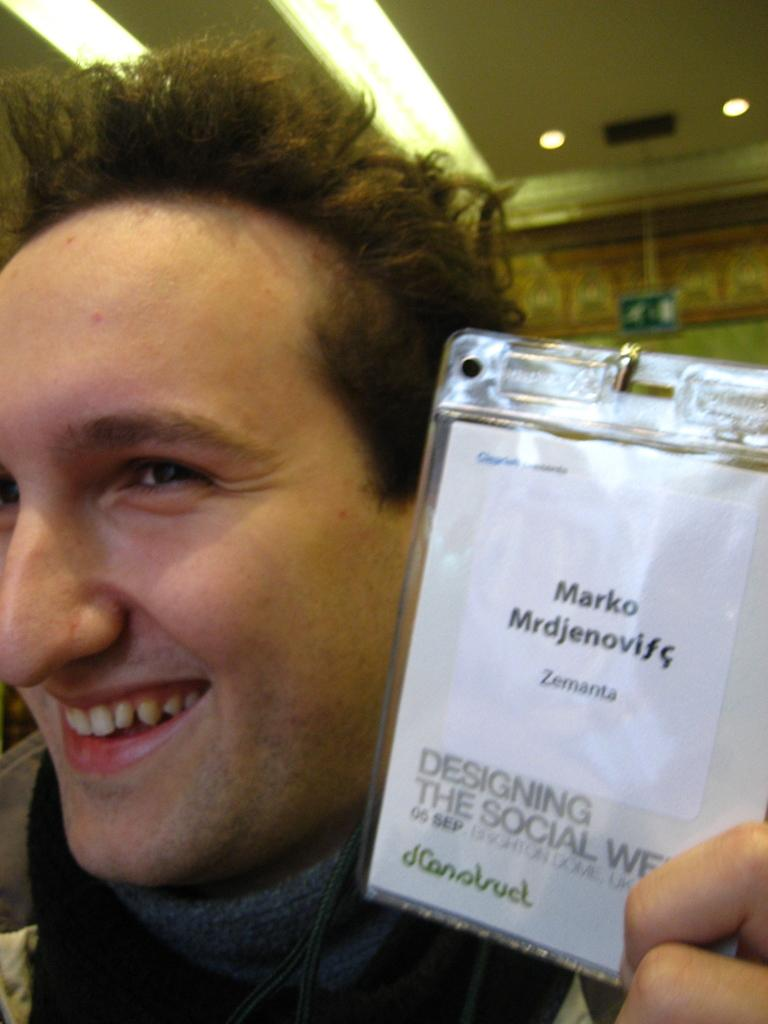What is the main subject of the image? There is a person in the image. What is the person holding in the image? The person is holding an object with text written on it. What can be seen in the background of the image? There is a wall and a board in the background of the image. What part of the building is visible in the image? The roof is visible in the image. What is on the roof in the image? There are lights on the roof. Can you hear the bells ringing in the image? There are no bells present in the image, so it is not possible to hear them ringing. 